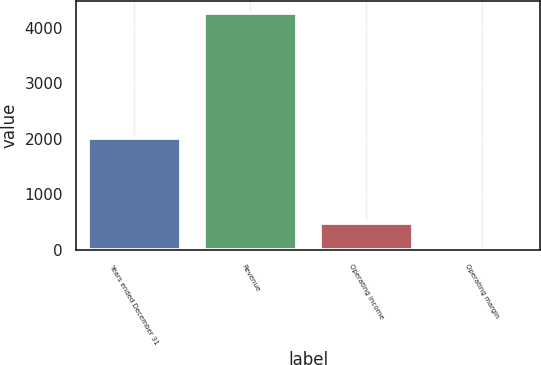Convert chart to OTSL. <chart><loc_0><loc_0><loc_500><loc_500><bar_chart><fcel>Years ended December 31<fcel>Revenue<fcel>Operating income<fcel>Operating margin<nl><fcel>2014<fcel>4264<fcel>485<fcel>11.4<nl></chart> 